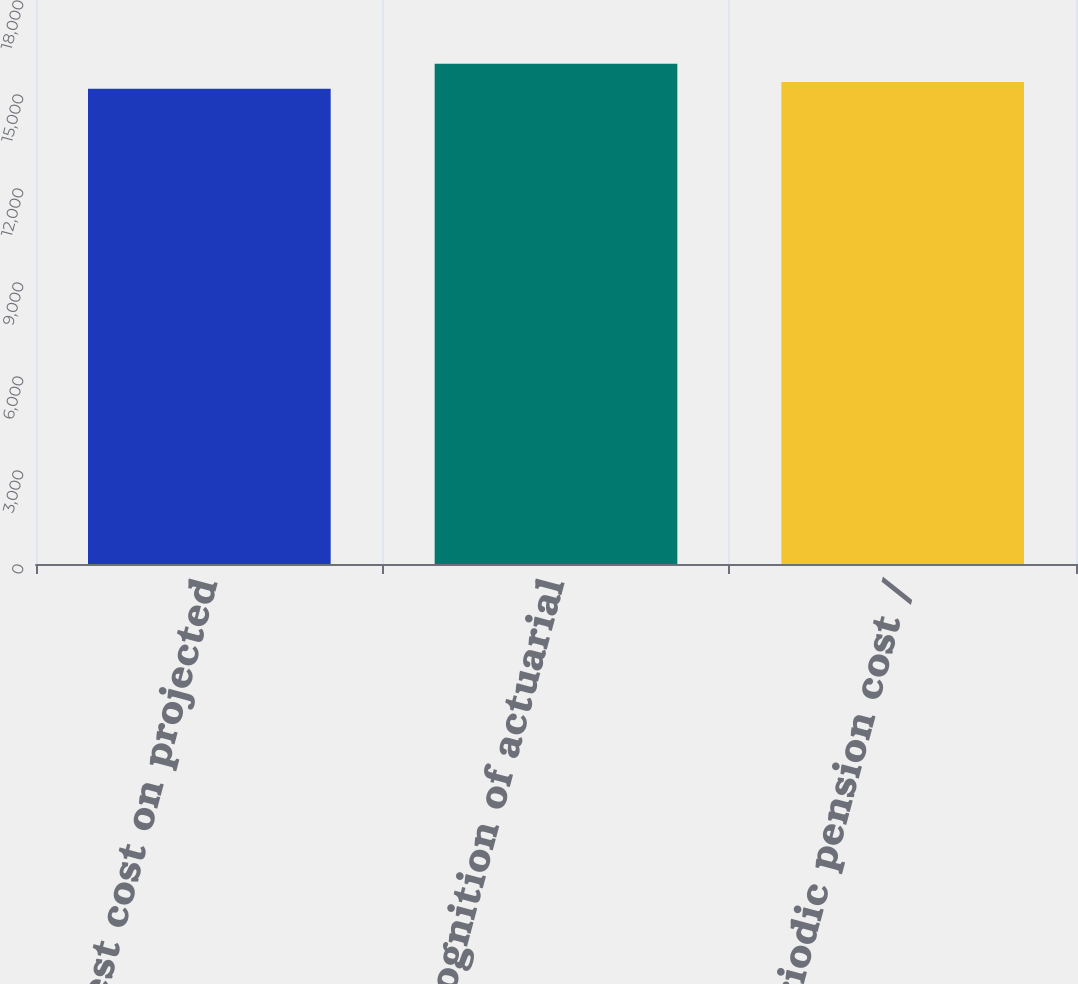Convert chart. <chart><loc_0><loc_0><loc_500><loc_500><bar_chart><fcel>Interest cost on projected<fcel>Recognition of actuarial<fcel>Net periodic pension cost /<nl><fcel>15168<fcel>15962<fcel>15380<nl></chart> 